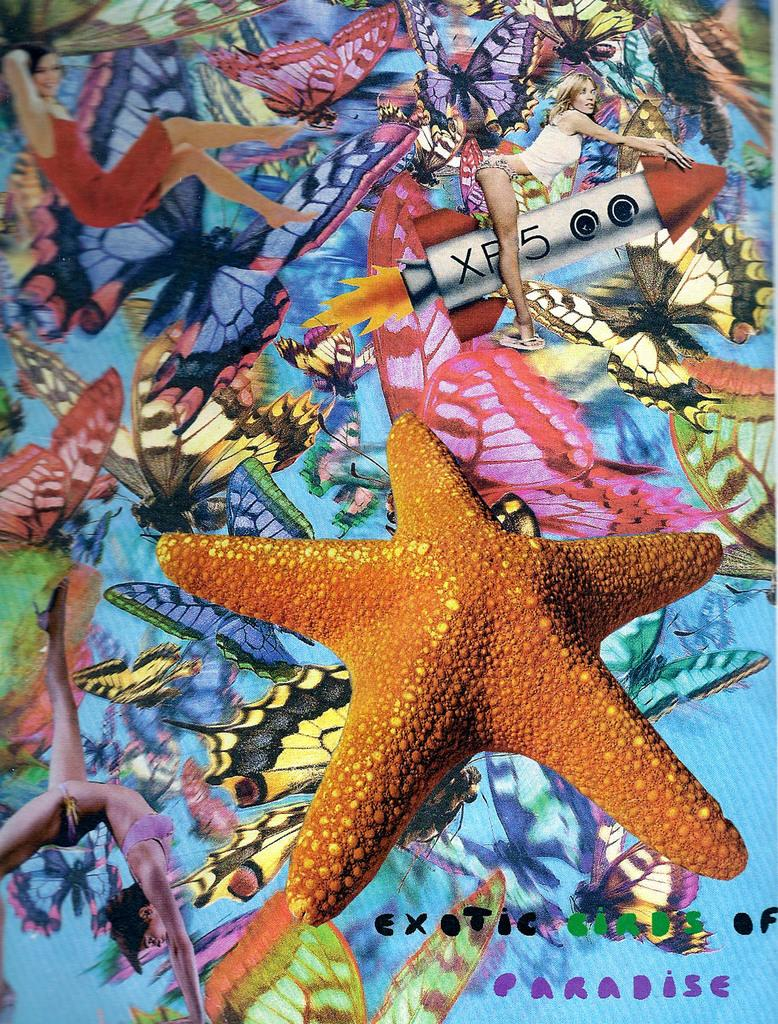What type of marine animal is present in the image? There is a starfish in the image. What else can be seen in the image besides the starfish? There are paintings of different objects and people in the image. Is there any text present in the image? Yes, there is some text on the right side of the image. Can you see any islands or fields in the image? No, there are no islands or fields present in the image. How many clovers are visible in the image? There are no clovers present in the image. 